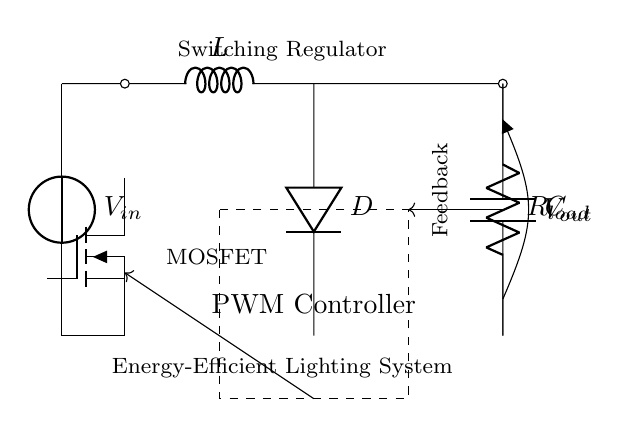What is the main purpose of this circuit? The main purpose of the circuit is indicated by the label "Energy-Efficient Lighting System," which suggests it aims to optimize power delivery to lighting components.
Answer: Energy-Efficient Lighting System What type of switch is used in this circuit? The switch used in this circuit is a MOSFET, as indicated by the label next to the component symbol.
Answer: MOSFET What component provides feedback in this circuit? The feedback component is depicted as an arrow leading from the output towards the controller, denoted by the label "Feedback."
Answer: Feedback What is the component labeled "C"? The component labeled "C" is a capacitor, which is a common component in switching regulators that stores electrical energy.
Answer: Capacitor What function does the diode serve in this circuit? The diode, labeled "D," allows current to flow in one direction only, preventing reverse current that could damage the circuit.
Answer: Prevents reverse current How does the PWM controller interact with the MOSFET? The PWM controller sends signals to the MOSFET, controlling its on-off states to regulate the output voltage based on feedback from the load.
Answer: Regulates output voltage What happens to voltage during the switching process? During the switching process, the voltage is modulated by the PWM controller to maintain a stable output level for the load.
Answer: Voltage modulation 